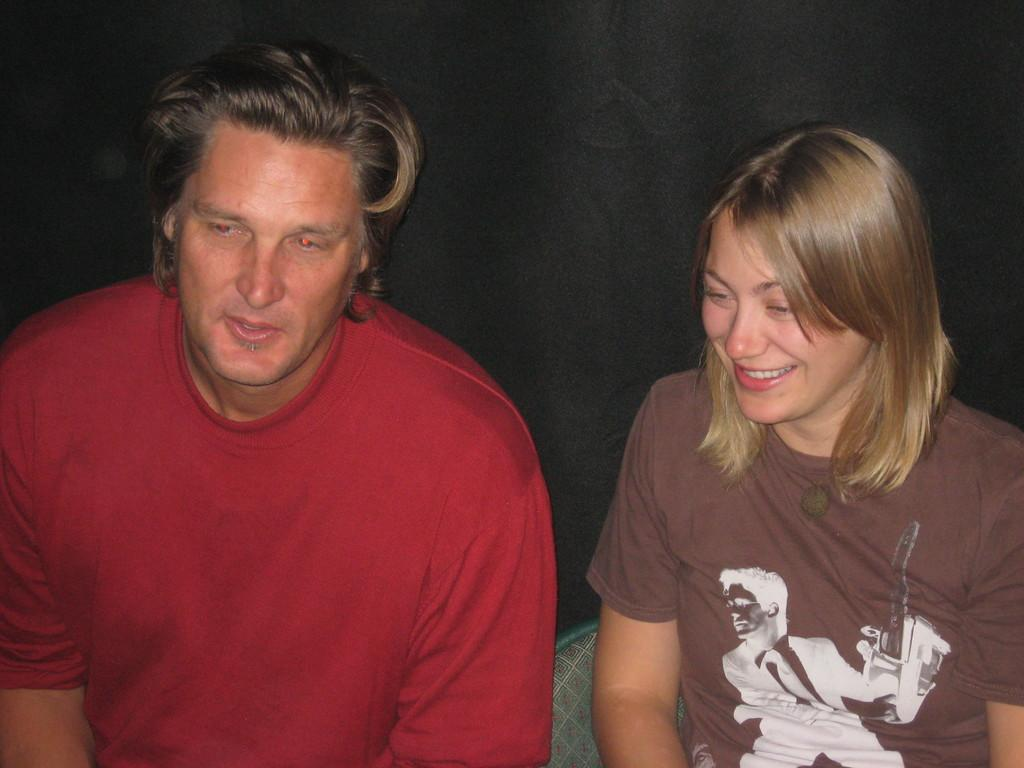How many people are in the image? There are two people in the image, a man and a woman. What are the man and woman doing in the image? Both the man and woman are sitting. Can you describe the expressions of the people in the image? The woman is smiling. What can be seen in the background of the image? The background of the image is dark. Are the man and woman wearing any clothing in the image? Yes, the man and woman are wearing clothes. What type of disease is the woman suffering from in the image? There is no indication of any disease in the image; the woman is simply smiling. Is it raining in the image? There is no mention of rain in the image, and the background is dark, not necessarily indicating rain. 